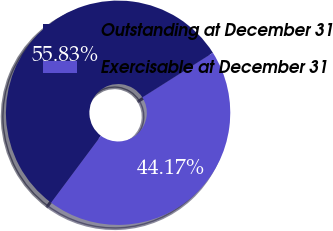Convert chart. <chart><loc_0><loc_0><loc_500><loc_500><pie_chart><fcel>Outstanding at December 31<fcel>Exercisable at December 31<nl><fcel>55.83%<fcel>44.17%<nl></chart> 